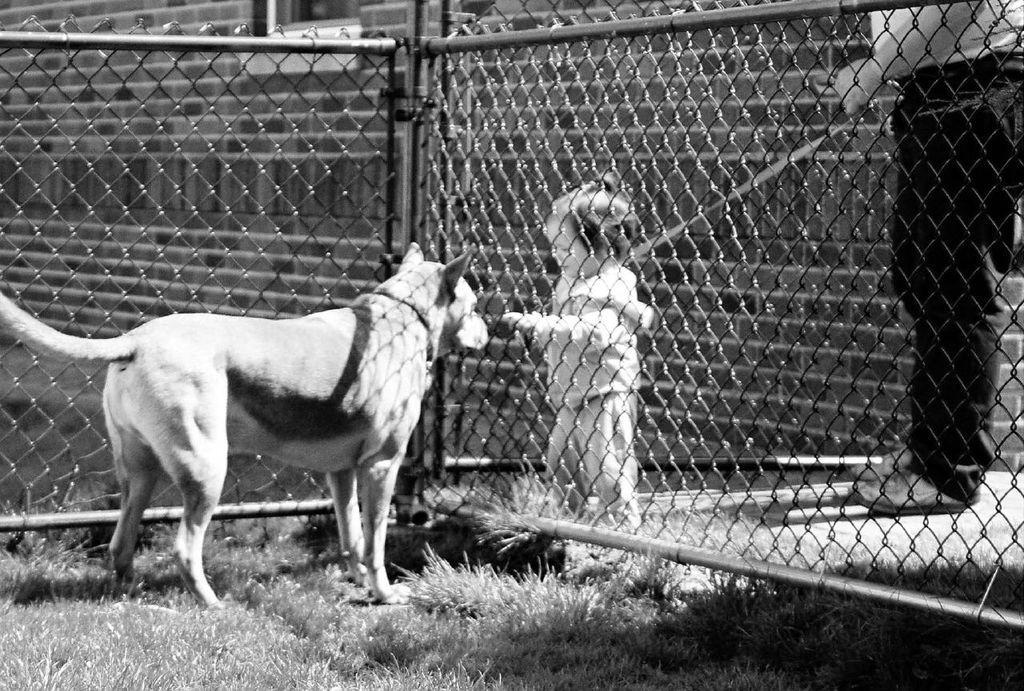Please provide a concise description of this image. In this picture I can see the dog on the left. I can see a metal grill fence. I can see a kid on the right side. I can see a person on the right side. I can see the grass. 